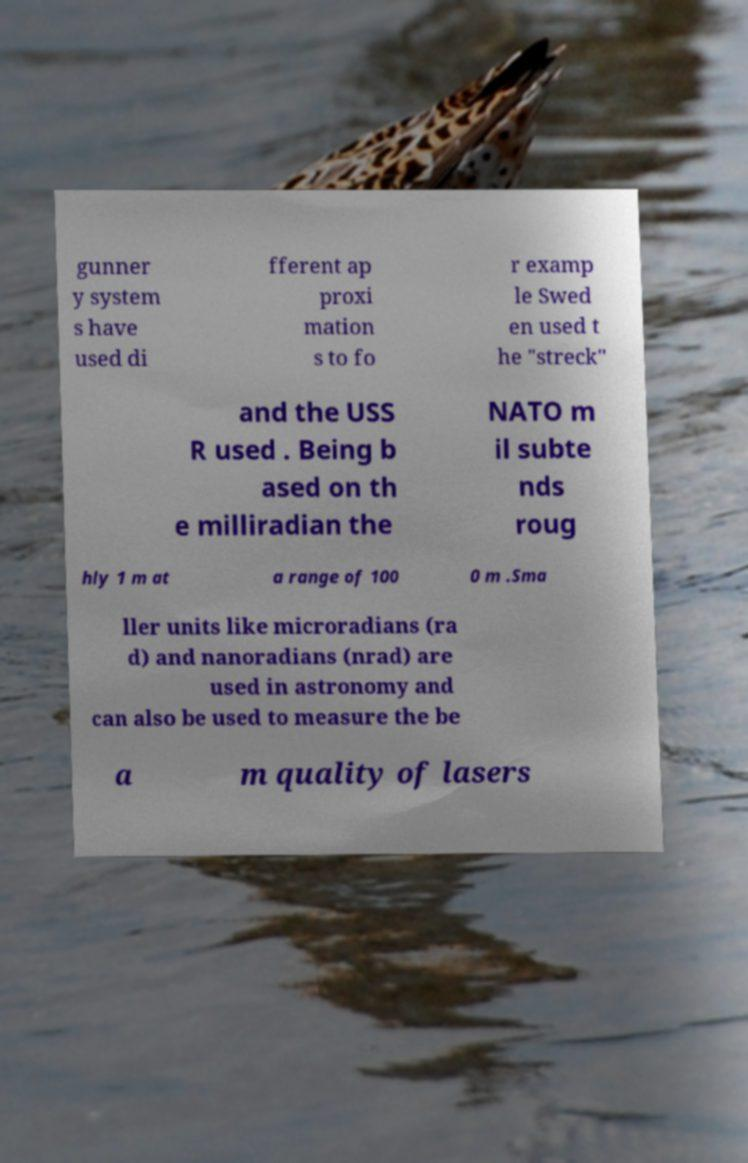Could you assist in decoding the text presented in this image and type it out clearly? gunner y system s have used di fferent ap proxi mation s to fo r examp le Swed en used t he "streck" and the USS R used . Being b ased on th e milliradian the NATO m il subte nds roug hly 1 m at a range of 100 0 m .Sma ller units like microradians (ra d) and nanoradians (nrad) are used in astronomy and can also be used to measure the be a m quality of lasers 